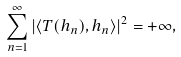Convert formula to latex. <formula><loc_0><loc_0><loc_500><loc_500>\sum _ { n = 1 } ^ { \infty } \left | \langle T ( h _ { n } ) , h _ { n } \rangle \right | ^ { 2 } = + \infty ,</formula> 